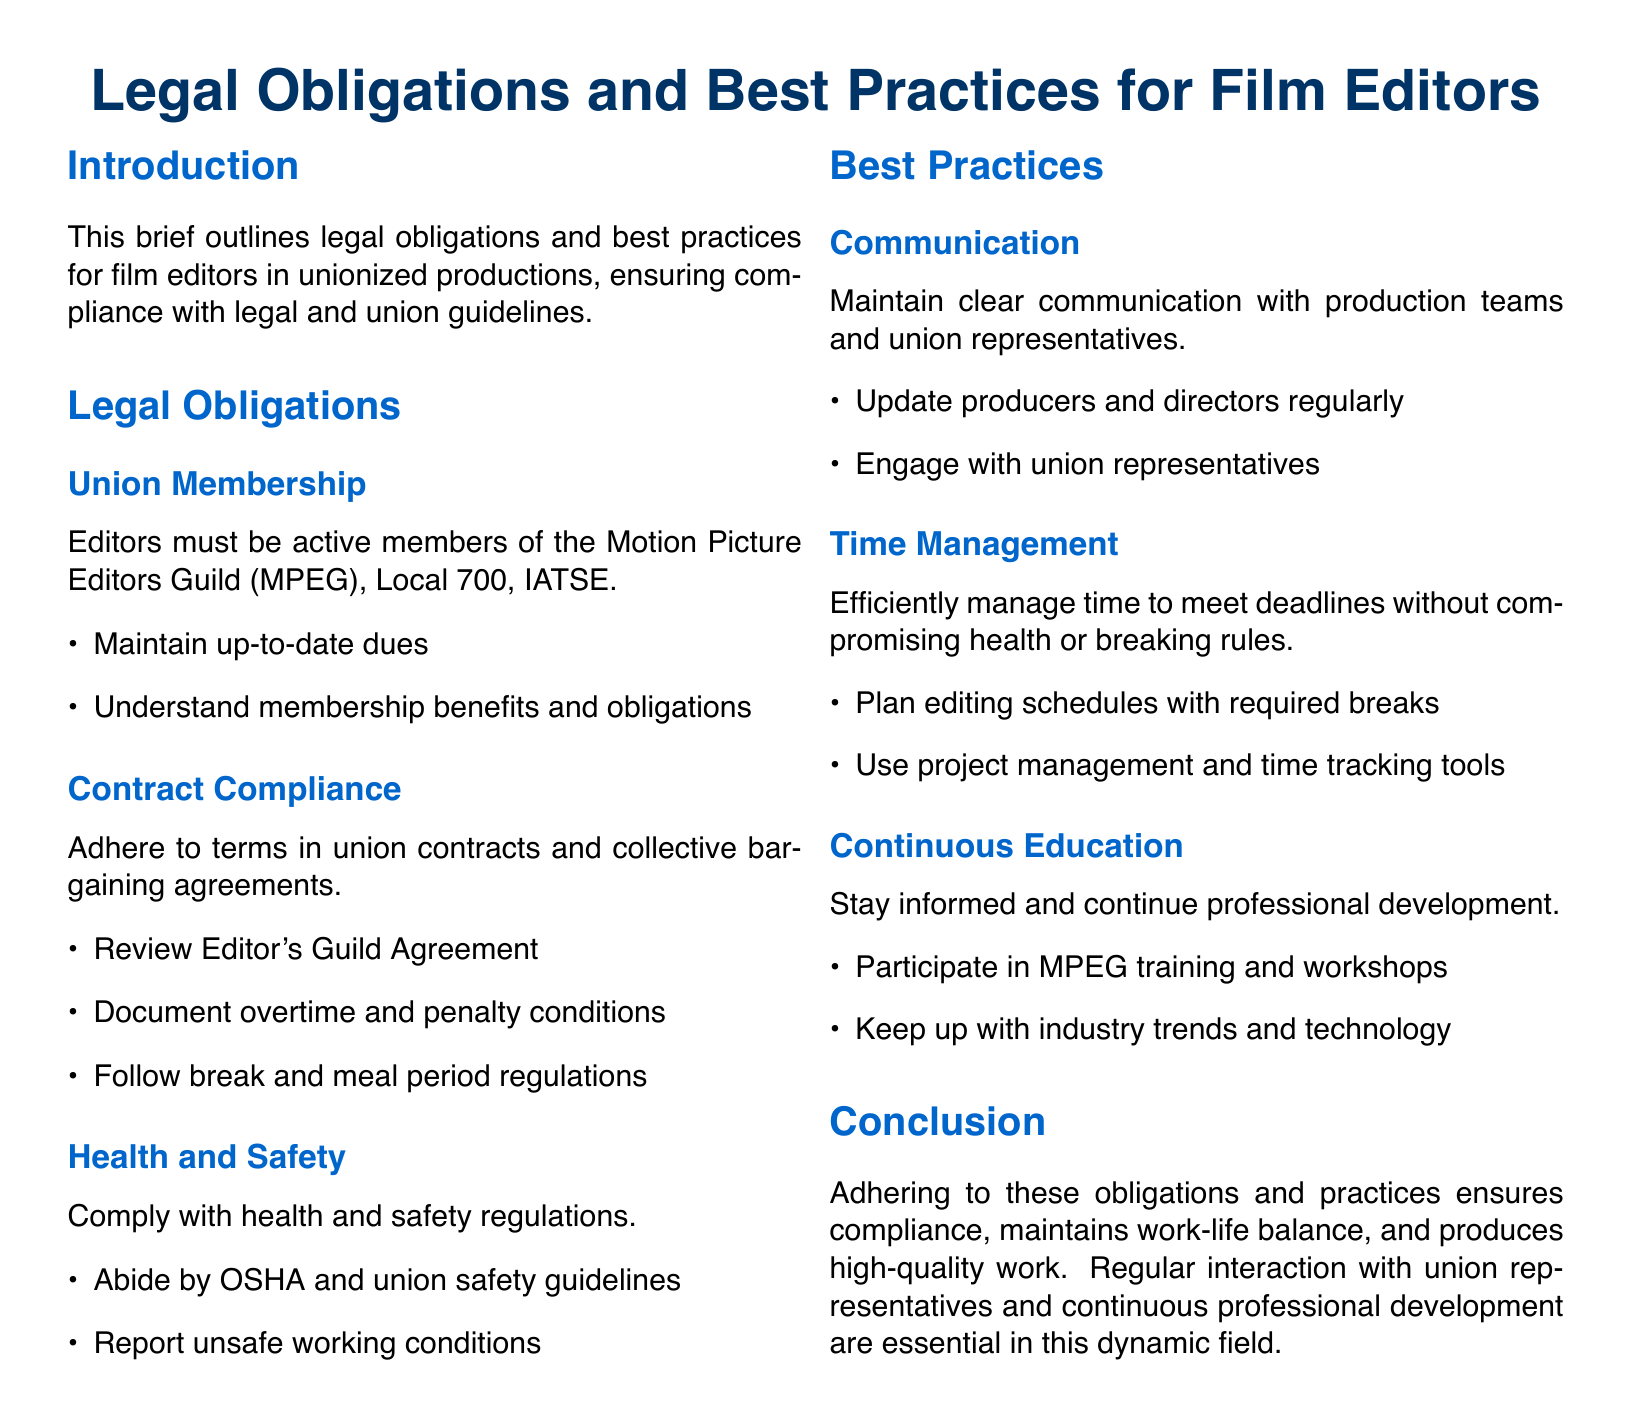what is the name of the guild mentioned? The document refers to the Motion Picture Editors Guild, specifically Local 700, IATSE, which is the relevant union for editors.
Answer: Motion Picture Editors Guild what must editors maintain to be active members? The brief specifies that editors must keep their dues up to date to maintain active membership in the union.
Answer: Up-to-date dues which agreement should editors review for contract compliance? The document states that editors should review the Editor's Guild Agreement for compliance with union contracts and collective bargaining agreements.
Answer: Editor's Guild Agreement who should editors maintain communication with? According to the document, editors should maintain clear communication with production teams and union representatives.
Answer: Production teams and union representatives how can editors efficiently manage their time? The best practices section suggests editors use project management and time tracking tools to manage their time effectively.
Answer: Project management and time tracking tools what regulation must editors comply with regarding health? The brief notes that editors must abide by OSHA and union safety guidelines for health and safety compliance.
Answer: OSHA and union safety guidelines what is an essential practice for ongoing professional growth? The document advises editors to participate in MPEG training and workshops as a means of continuous education.
Answer: MPEG training and workshops what is emphasized in the conclusion related to union representatives? The conclusion stresses that regular interaction with union representatives is essential for maintaining compliance and professional development in this industry.
Answer: Regular interaction with union representatives how should editors plan their schedules? The best practices section mentions that editors should plan editing schedules with required breaks to meet deadlines without compromising health.
Answer: Required breaks 